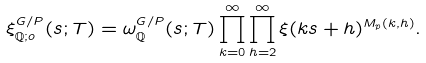Convert formula to latex. <formula><loc_0><loc_0><loc_500><loc_500>\xi ^ { G / P } _ { \mathbb { Q } ; o } ( s ; T ) = \omega ^ { G / P } _ { \mathbb { Q } } ( s ; T ) \prod _ { k = 0 } ^ { \infty } \prod _ { h = 2 } ^ { \infty } \xi ( k s + h ) ^ { M _ { p } ( k , h ) } .</formula> 